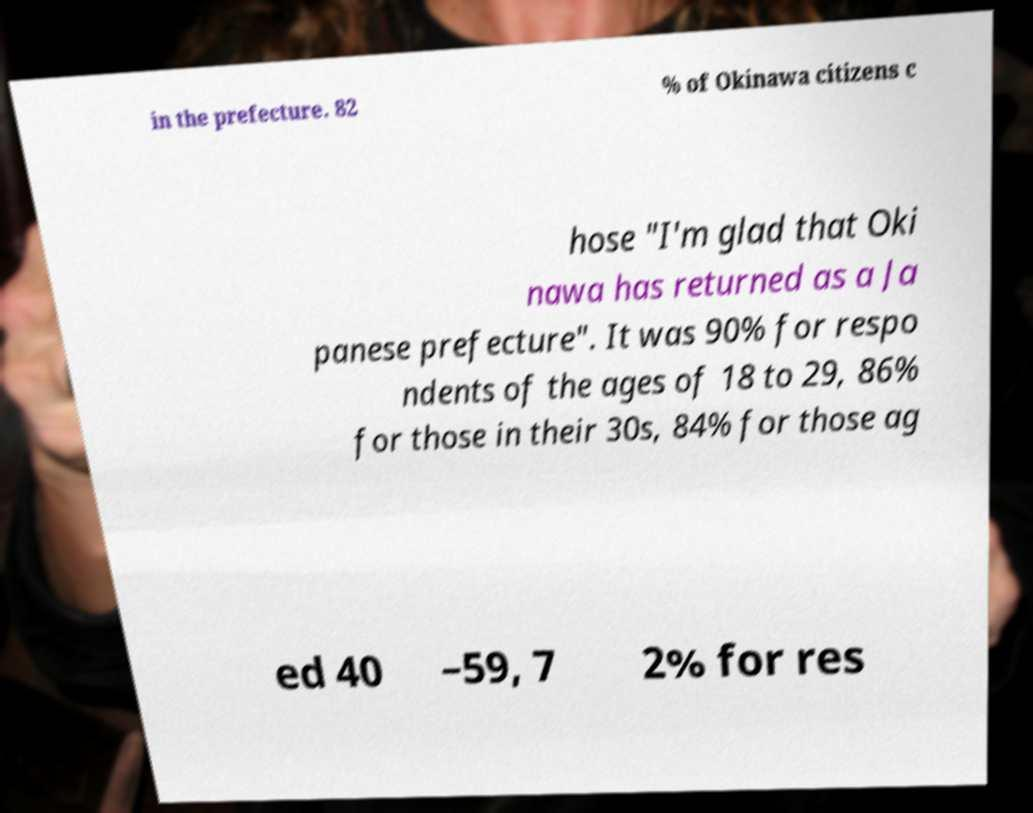Can you read and provide the text displayed in the image?This photo seems to have some interesting text. Can you extract and type it out for me? in the prefecture. 82 % of Okinawa citizens c hose "I'm glad that Oki nawa has returned as a Ja panese prefecture". It was 90% for respo ndents of the ages of 18 to 29, 86% for those in their 30s, 84% for those ag ed 40 –59, 7 2% for res 